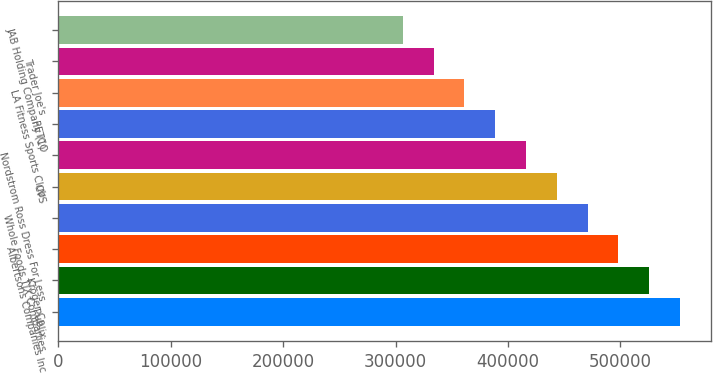Convert chart to OTSL. <chart><loc_0><loc_0><loc_500><loc_500><bar_chart><fcel>Publix<fcel>Kroger Co<fcel>Albertsons Companies Inc<fcel>Whole Foods TJX Companies<fcel>CVS<fcel>Nordstrom Ross Dress For Less<fcel>PETCO<fcel>LA Fitness Sports Club<fcel>Trader Joe's<fcel>JAB Holding Company (1)<nl><fcel>552895<fcel>525503<fcel>498110<fcel>470718<fcel>443326<fcel>415934<fcel>388541<fcel>361149<fcel>333757<fcel>306364<nl></chart> 